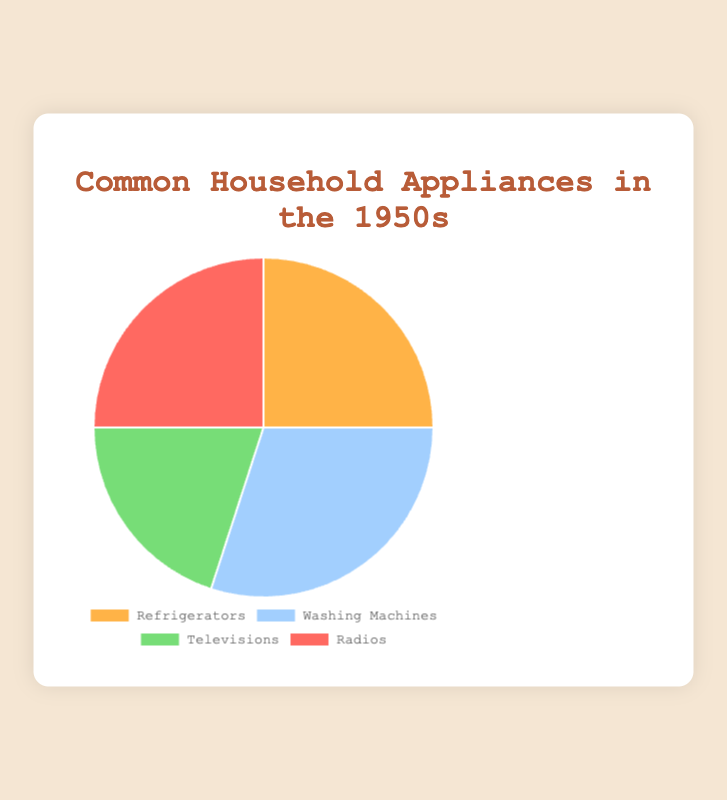What percentage of the pie chart is taken up by Refrigerators and Radios combined? To find the combined percentage, add the percentage for Refrigerators (25%) and Radios (25%). Therefore, 25% + 25% = 50%.
Answer: 50% Which appliance takes up the largest section of the pie chart? The largest percentage value in the data is for Washing Machines, which is 30%.
Answer: Washing Machines Is the proportion of Washing Machines greater than the proportion of Televisions? If so, by how much? The percentage for Washing Machines is 30% while for Televisions it is 20%. Thus, 30% is greater than 20% by 10%.
Answer: 10% What is the average percentage of all the appliances? To find the average, sum all the percentages and divide by the number of appliances. (25% + 30% + 20% + 25%) = 100%, and there are 4 appliances. 100% / 4 = 25%.
Answer: 25% Does the section for Refrigerators share the same percentage as any other appliance in the chart? Yes, the section for Refrigerators (25%) shares the same percentage as the section for Radios (25%).
Answer: Yes What is the combined percentage of appliances represented by Washing Machines and Televisions in the chart? Add the percentages for Washing Machines (30%) and Televisions (20%). Therefore, 30% + 20% = 50%.
Answer: 50% If we remove the percentage of Radios from the total, what is the remaining percentage? Subtract the percentage of Radios (25%) from the total (100%). Therefore, 100% - 25% = 75%.
Answer: 75% Which appliance has the smallest representation in the pie chart? The smallest percentage value in the data is for Televisions, which is 20%.
Answer: Televisions By what factor is the percentage of Washing Machines greater than the percentage of Televisions? The percentage for Washing Machines is 30% and for Televisions is 20%. 30% / 20% = 1.5. Thus, the Washing Machines' percentage is 1.5 times the Televisions' percentage.
Answer: 1.5 